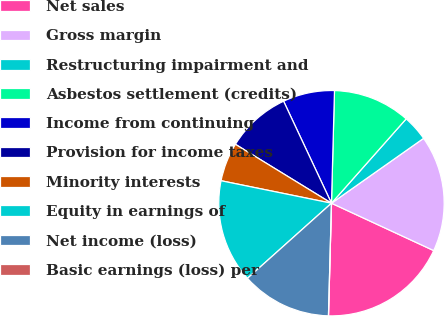<chart> <loc_0><loc_0><loc_500><loc_500><pie_chart><fcel>Net sales<fcel>Gross margin<fcel>Restructuring impairment and<fcel>Asbestos settlement (credits)<fcel>Income from continuing<fcel>Provision for income taxes<fcel>Minority interests<fcel>Equity in earnings of<fcel>Net income (loss)<fcel>Basic earnings (loss) per<nl><fcel>18.52%<fcel>16.67%<fcel>3.7%<fcel>11.11%<fcel>7.41%<fcel>9.26%<fcel>5.56%<fcel>14.81%<fcel>12.96%<fcel>0.0%<nl></chart> 